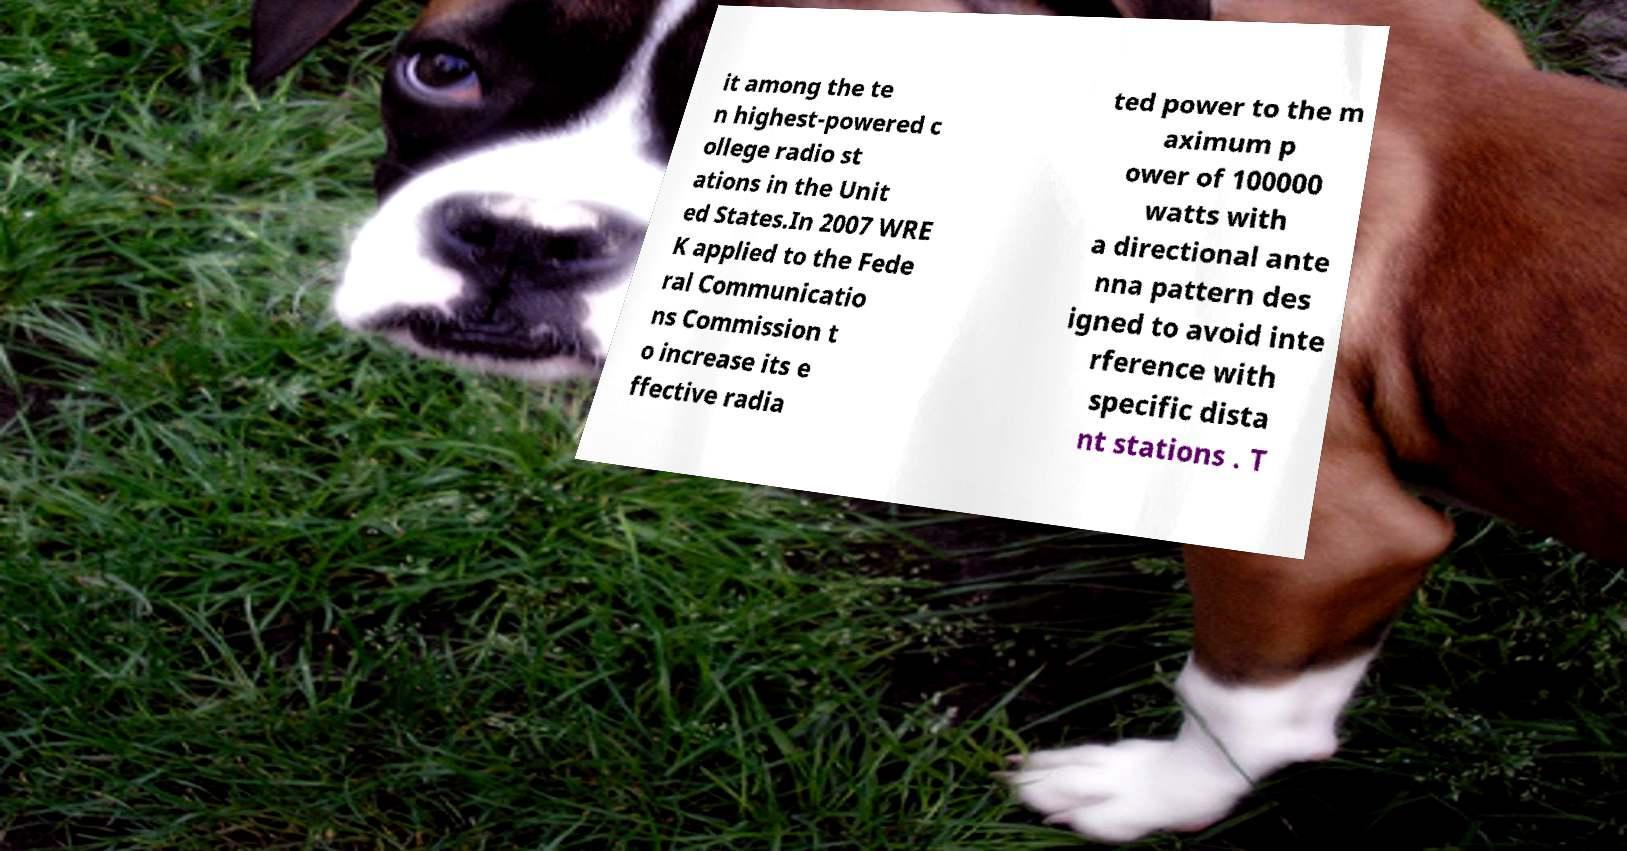I need the written content from this picture converted into text. Can you do that? it among the te n highest-powered c ollege radio st ations in the Unit ed States.In 2007 WRE K applied to the Fede ral Communicatio ns Commission t o increase its e ffective radia ted power to the m aximum p ower of 100000 watts with a directional ante nna pattern des igned to avoid inte rference with specific dista nt stations . T 